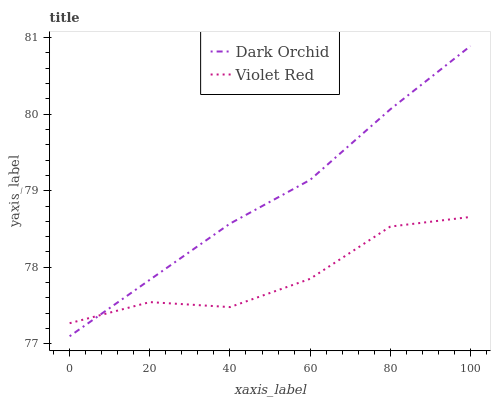Does Dark Orchid have the minimum area under the curve?
Answer yes or no. No. Is Dark Orchid the roughest?
Answer yes or no. No. 